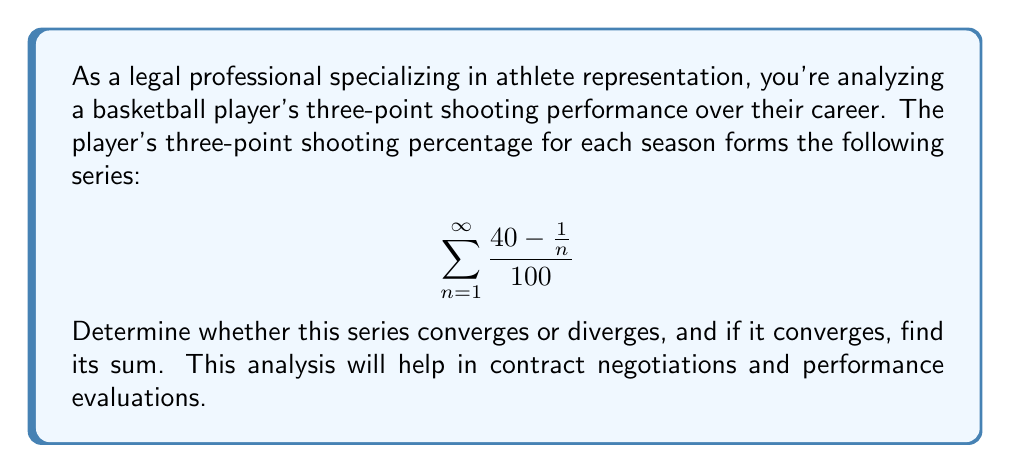Teach me how to tackle this problem. Let's approach this step-by-step:

1) First, we need to examine the general term of the series:

   $$a_n = \frac{40 - \frac{1}{n}}{100} = \frac{40}{100} - \frac{1}{100n} = 0.4 - \frac{1}{100n}$$

2) To determine convergence, we'll use the limit comparison test with the series $\sum \frac{1}{n}$:

   $$\lim_{n \to \infty} \frac{a_n}{\frac{1}{n}} = \lim_{n \to \infty} \frac{0.4 - \frac{1}{100n}}{\frac{1}{n}} = \lim_{n \to \infty} (0.4n - \frac{1}{100}) = \infty$$

3) Since this limit is infinite, and $\sum \frac{1}{n}$ diverges, our series must also diverge.

4) However, we can find the limit of the partial sums:

   $$\lim_{N \to \infty} \sum_{n=1}^{N} (0.4 - \frac{1}{100n}) = \lim_{N \to \infty} (0.4N - \frac{1}{100}\sum_{n=1}^{N}\frac{1}{n})$$

5) We know that $\sum_{n=1}^{N}\frac{1}{n}$ is the harmonic series, which grows logarithmically:

   $$\lim_{N \to \infty} (0.4N - \frac{1}{100}\ln(N) - \frac{\gamma}{100})$$

   Where $\gamma$ is the Euler-Mascheroni constant.

6) As $N$ approaches infinity, this expression will grow without bound, confirming the divergence of the series.

Therefore, the series diverges, representing an indefinite improvement in the player's three-point shooting percentage over their career.
Answer: The series diverges. 